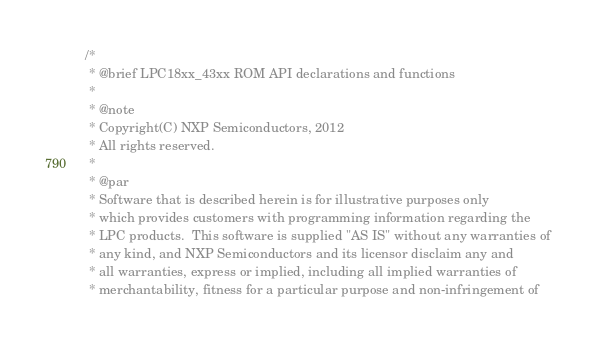<code> <loc_0><loc_0><loc_500><loc_500><_C_>/*
 * @brief LPC18xx_43xx ROM API declarations and functions
 *
 * @note
 * Copyright(C) NXP Semiconductors, 2012
 * All rights reserved.
 *
 * @par
 * Software that is described herein is for illustrative purposes only
 * which provides customers with programming information regarding the
 * LPC products.  This software is supplied "AS IS" without any warranties of
 * any kind, and NXP Semiconductors and its licensor disclaim any and
 * all warranties, express or implied, including all implied warranties of
 * merchantability, fitness for a particular purpose and non-infringement of</code> 